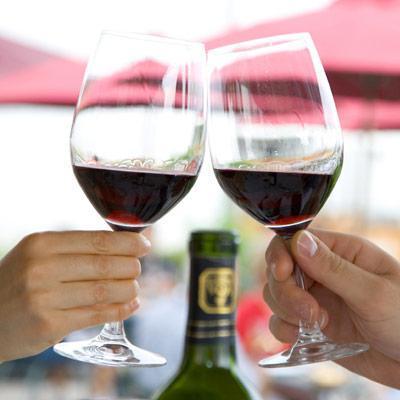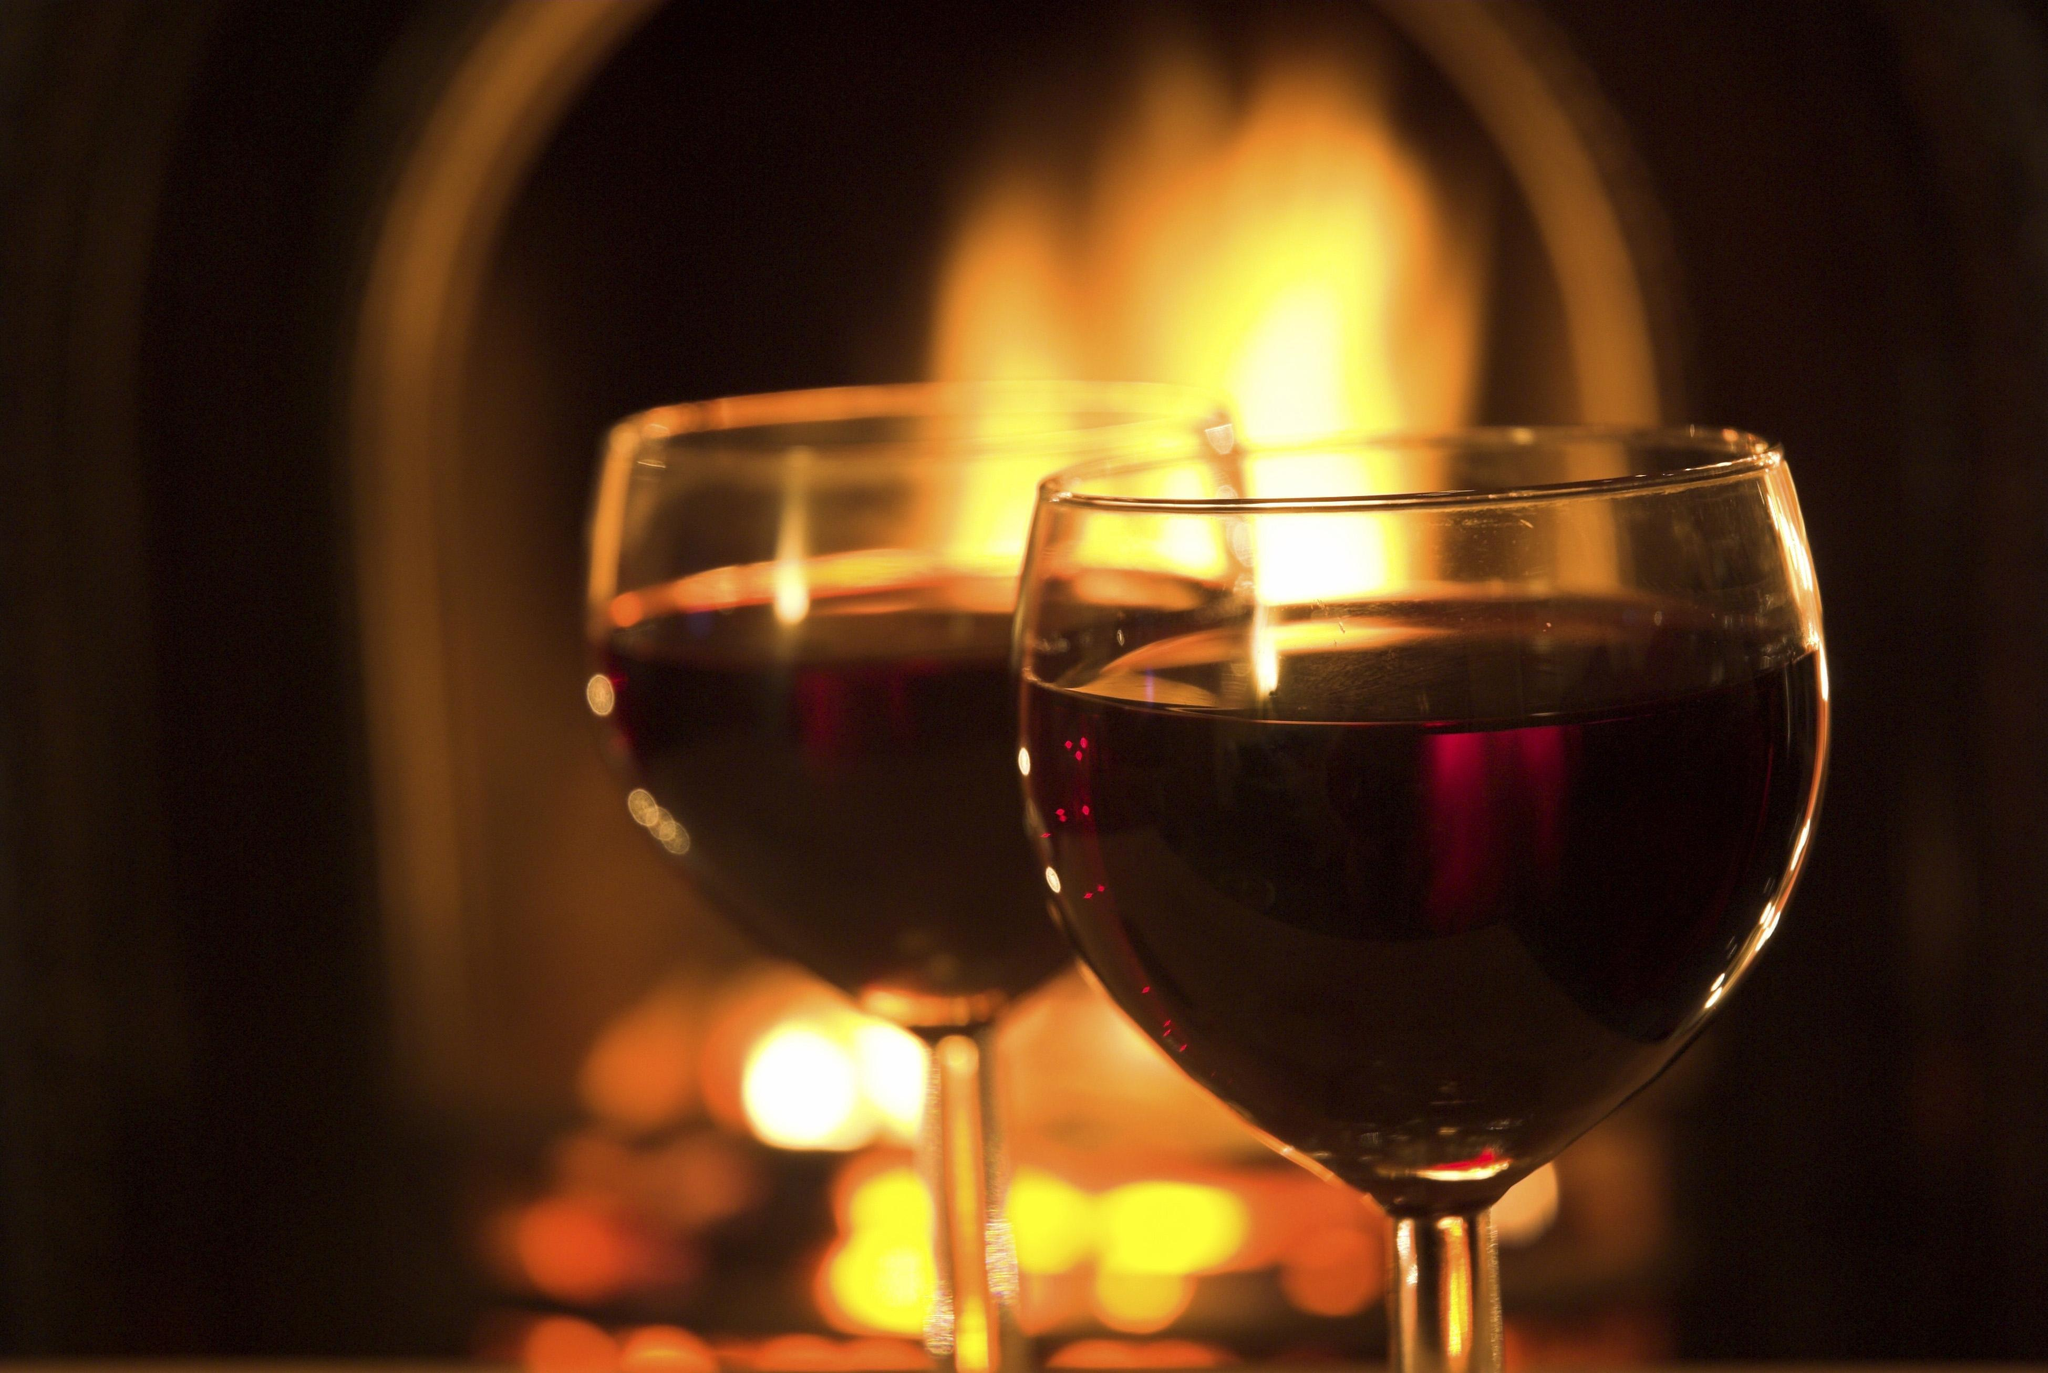The first image is the image on the left, the second image is the image on the right. Given the left and right images, does the statement "At least one image has a flame or candle in the background." hold true? Answer yes or no. Yes. The first image is the image on the left, the second image is the image on the right. Evaluate the accuracy of this statement regarding the images: "No hands are holding the wine glasses in the right-hand image.". Is it true? Answer yes or no. Yes. 